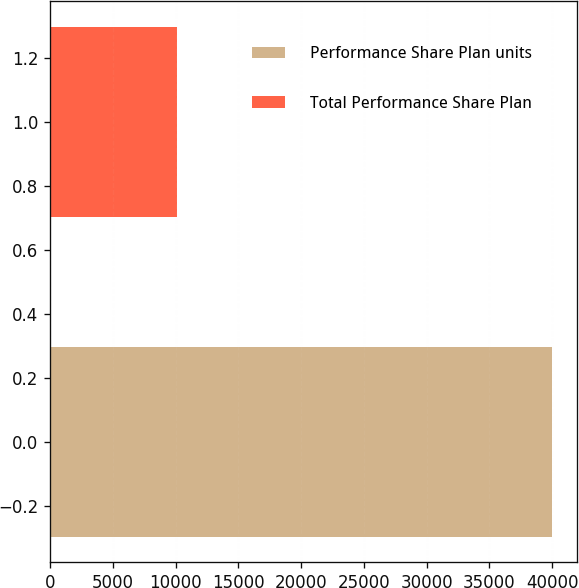Convert chart to OTSL. <chart><loc_0><loc_0><loc_500><loc_500><bar_chart><fcel>Performance Share Plan units<fcel>Total Performance Share Plan<nl><fcel>39977<fcel>10133<nl></chart> 